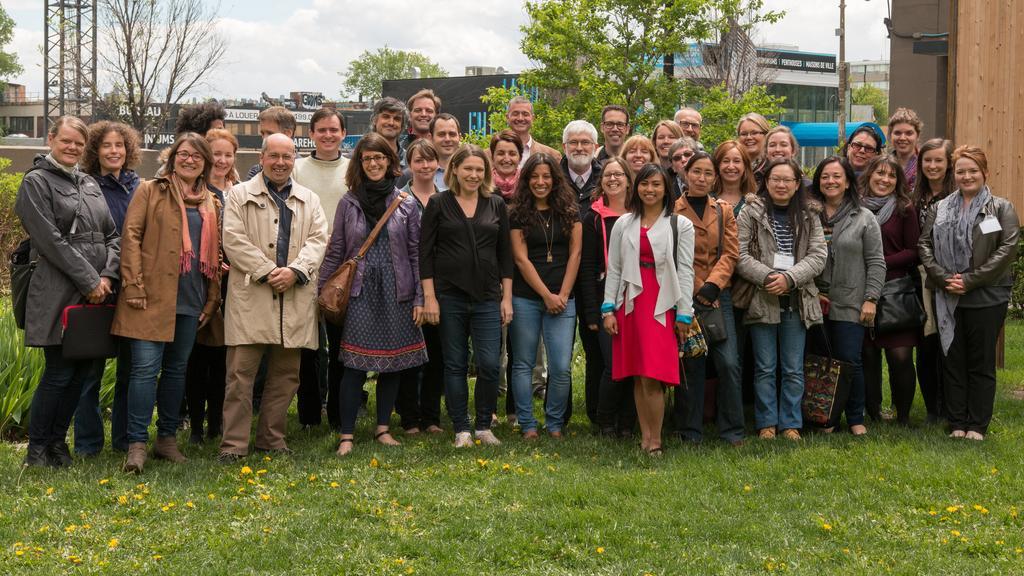Please provide a concise description of this image. In this image the are a group of people standing with a smile on their face, behind them there are poles, metal structures, trees and buildings. 